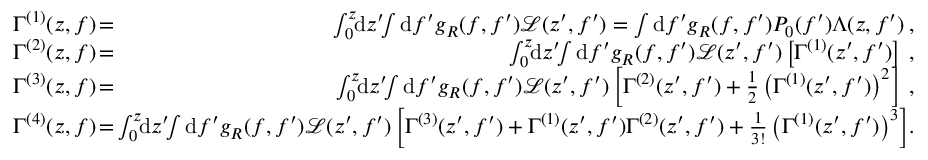<formula> <loc_0><loc_0><loc_500><loc_500>\begin{array} { r l r } { \Gamma ^ { ( 1 ) } ( z , f ) \, } & { = } & { \, \int _ { 0 } ^ { z } \, d z ^ { \prime } \, \int d f ^ { \prime } g _ { R } ( f , f ^ { \prime } ) \mathcal { L } ( z ^ { \prime } , f ^ { \prime } ) = \int d f ^ { \prime } g _ { R } ( f , f ^ { \prime } ) P _ { 0 } ( f ^ { \prime } ) \Lambda ( z , f ^ { \prime } ) \, , } \\ { \Gamma ^ { ( 2 ) } ( z , f ) \, } & { = } & { \, \int _ { 0 } ^ { z } \, d z ^ { \prime } \, \int d f ^ { \prime } g _ { R } ( f , f ^ { \prime } ) \mathcal { L } ( z ^ { \prime } , f ^ { \prime } ) \left [ \Gamma ^ { ( 1 ) } ( z ^ { \prime } , f ^ { \prime } ) \right ] \, , } \\ { \Gamma ^ { ( 3 ) } ( z , f ) \, } & { = } & { \, \int _ { 0 } ^ { z } \, d z ^ { \prime } \, \int d f ^ { \prime } g _ { R } ( f , f ^ { \prime } ) \mathcal { L } ( z ^ { \prime } , f ^ { \prime } ) \left [ \Gamma ^ { ( 2 ) } ( z ^ { \prime } , f ^ { \prime } ) + \frac { 1 } { 2 } \left ( \Gamma ^ { ( 1 ) } ( z ^ { \prime } , f ^ { \prime } ) \right ) ^ { 2 } \right ] \, , } \\ { \Gamma ^ { ( 4 ) } ( z , f ) \, } & { = } & { \, \int _ { 0 } ^ { z } \, d z ^ { \prime } \, \int d f ^ { \prime } g _ { R } ( f , f ^ { \prime } ) \mathcal { L } ( z ^ { \prime } , f ^ { \prime } ) \left [ \Gamma ^ { ( 3 ) } ( z ^ { \prime } , f ^ { \prime } ) + \Gamma ^ { ( 1 ) } ( z ^ { \prime } , f ^ { \prime } ) \Gamma ^ { ( 2 ) } ( z ^ { \prime } , f ^ { \prime } ) + \frac { 1 } { 3 ! } \left ( \Gamma ^ { ( 1 ) } ( z ^ { \prime } , f ^ { \prime } ) \right ) ^ { 3 } \right ] \, . } \end{array}</formula> 